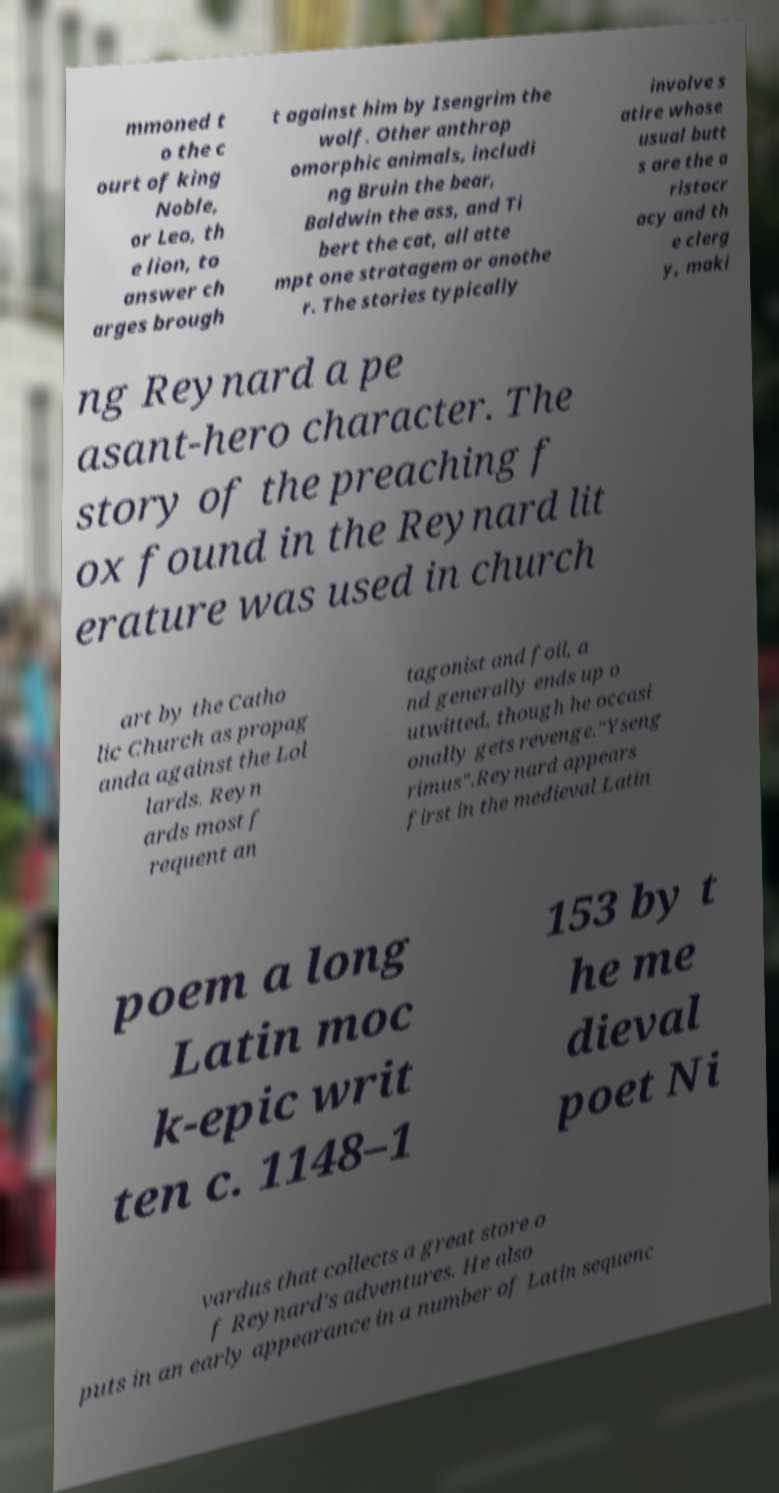Can you read and provide the text displayed in the image?This photo seems to have some interesting text. Can you extract and type it out for me? mmoned t o the c ourt of king Noble, or Leo, th e lion, to answer ch arges brough t against him by Isengrim the wolf. Other anthrop omorphic animals, includi ng Bruin the bear, Baldwin the ass, and Ti bert the cat, all atte mpt one stratagem or anothe r. The stories typically involve s atire whose usual butt s are the a ristocr acy and th e clerg y, maki ng Reynard a pe asant-hero character. The story of the preaching f ox found in the Reynard lit erature was used in church art by the Catho lic Church as propag anda against the Lol lards. Reyn ards most f requent an tagonist and foil, a nd generally ends up o utwitted, though he occasi onally gets revenge."Yseng rimus".Reynard appears first in the medieval Latin poem a long Latin moc k-epic writ ten c. 1148–1 153 by t he me dieval poet Ni vardus that collects a great store o f Reynard's adventures. He also puts in an early appearance in a number of Latin sequenc 